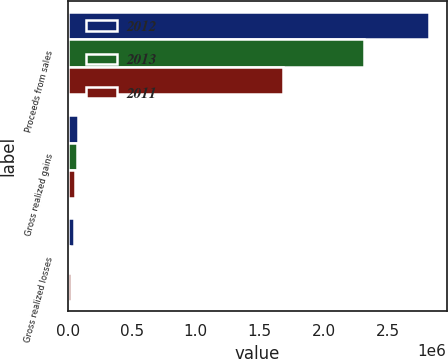Convert chart. <chart><loc_0><loc_0><loc_500><loc_500><stacked_bar_chart><ecel><fcel>Proceeds from sales<fcel>Gross realized gains<fcel>Gross realized losses<nl><fcel>2012<fcel>2.82118e+06<fcel>81921<fcel>50667<nl><fcel>2013<fcel>2.31454e+06<fcel>68697<fcel>12597<nl><fcel>2011<fcel>1.67955e+06<fcel>57120<fcel>20925<nl></chart> 